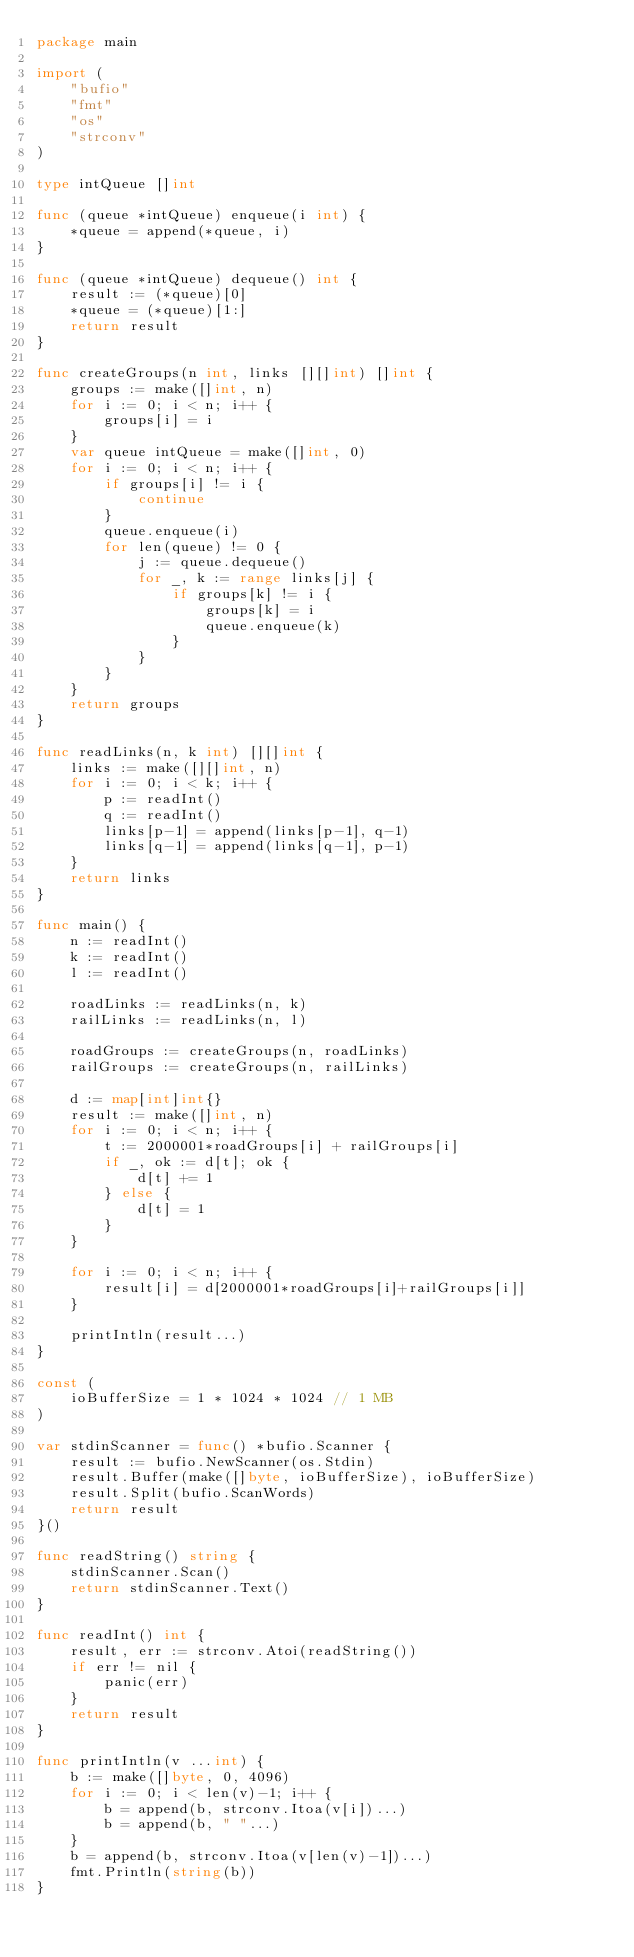<code> <loc_0><loc_0><loc_500><loc_500><_Go_>package main
 
import (
	"bufio"
	"fmt"
	"os"
	"strconv"
)
 
type intQueue []int
 
func (queue *intQueue) enqueue(i int) {
	*queue = append(*queue, i)
}
 
func (queue *intQueue) dequeue() int {
	result := (*queue)[0]
	*queue = (*queue)[1:]
	return result
}
 
func createGroups(n int, links [][]int) []int {
	groups := make([]int, n)
	for i := 0; i < n; i++ {
		groups[i] = i
	}
	var queue intQueue = make([]int, 0)
	for i := 0; i < n; i++ {
		if groups[i] != i {
			continue
		}
		queue.enqueue(i)
		for len(queue) != 0 {
			j := queue.dequeue()
			for _, k := range links[j] {
				if groups[k] != i {
					groups[k] = i
					queue.enqueue(k)
				}
			}
		}
	}
	return groups
}
 
func readLinks(n, k int) [][]int {
	links := make([][]int, n)
	for i := 0; i < k; i++ {
		p := readInt()
		q := readInt()
		links[p-1] = append(links[p-1], q-1)
		links[q-1] = append(links[q-1], p-1)
	}
	return links
}
 
func main() {
	n := readInt()
	k := readInt()
	l := readInt()
 
	roadLinks := readLinks(n, k)
	railLinks := readLinks(n, l)
 
	roadGroups := createGroups(n, roadLinks)
	railGroups := createGroups(n, railLinks)
 
	d := map[int]int{}
	result := make([]int, n)
	for i := 0; i < n; i++ {
		t := 2000001*roadGroups[i] + railGroups[i]
		if _, ok := d[t]; ok {
			d[t] += 1
		} else {
			d[t] = 1
		}
	}
 
	for i := 0; i < n; i++ {
		result[i] = d[2000001*roadGroups[i]+railGroups[i]]
	}
 
	printIntln(result...)
}
 
const (
	ioBufferSize = 1 * 1024 * 1024 // 1 MB
)
 
var stdinScanner = func() *bufio.Scanner {
	result := bufio.NewScanner(os.Stdin)
	result.Buffer(make([]byte, ioBufferSize), ioBufferSize)
	result.Split(bufio.ScanWords)
	return result
}()
 
func readString() string {
	stdinScanner.Scan()
	return stdinScanner.Text()
}
 
func readInt() int {
	result, err := strconv.Atoi(readString())
	if err != nil {
		panic(err)
	}
	return result
}
 
func printIntln(v ...int) {
	b := make([]byte, 0, 4096)
	for i := 0; i < len(v)-1; i++ {
		b = append(b, strconv.Itoa(v[i])...)
		b = append(b, " "...)
	}
	b = append(b, strconv.Itoa(v[len(v)-1])...)
	fmt.Println(string(b))
}</code> 